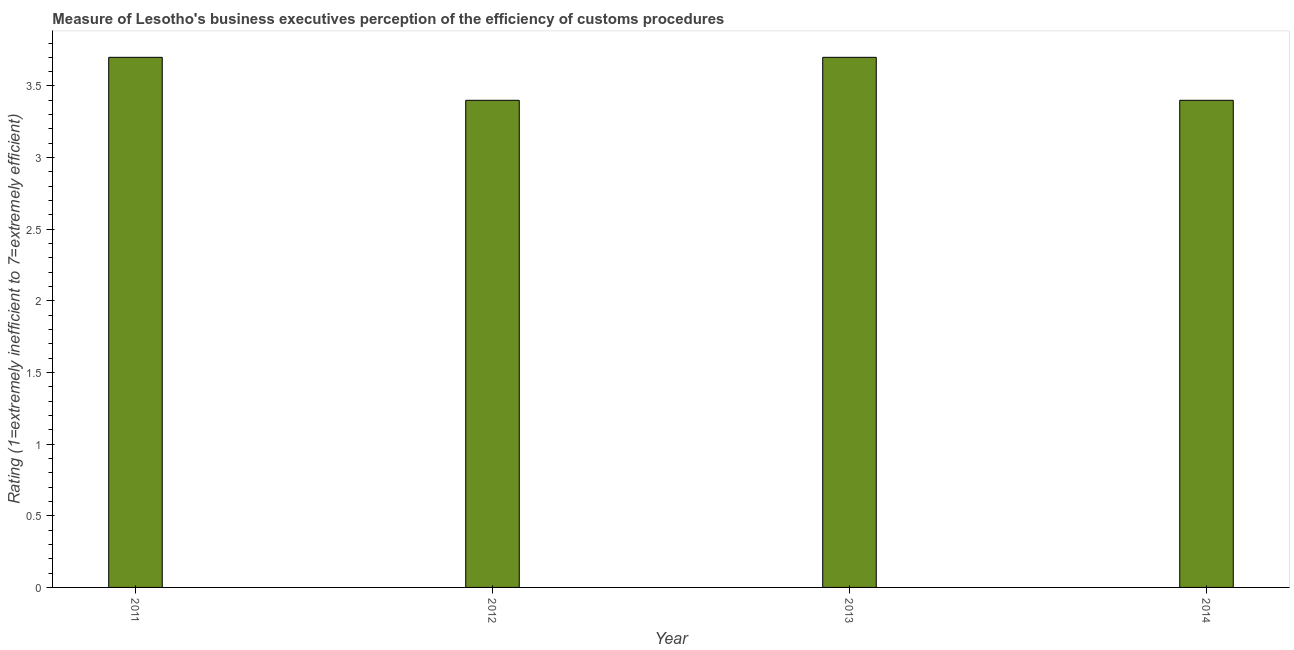Does the graph contain any zero values?
Make the answer very short. No. Does the graph contain grids?
Your answer should be very brief. No. What is the title of the graph?
Your answer should be very brief. Measure of Lesotho's business executives perception of the efficiency of customs procedures. What is the label or title of the X-axis?
Provide a short and direct response. Year. What is the label or title of the Y-axis?
Provide a succinct answer. Rating (1=extremely inefficient to 7=extremely efficient). What is the rating measuring burden of customs procedure in 2011?
Provide a short and direct response. 3.7. Across all years, what is the minimum rating measuring burden of customs procedure?
Your answer should be compact. 3.4. In which year was the rating measuring burden of customs procedure maximum?
Offer a very short reply. 2011. In which year was the rating measuring burden of customs procedure minimum?
Give a very brief answer. 2012. What is the sum of the rating measuring burden of customs procedure?
Your answer should be compact. 14.2. What is the average rating measuring burden of customs procedure per year?
Your answer should be very brief. 3.55. What is the median rating measuring burden of customs procedure?
Provide a short and direct response. 3.55. In how many years, is the rating measuring burden of customs procedure greater than 3.4 ?
Your response must be concise. 2. Do a majority of the years between 2011 and 2013 (inclusive) have rating measuring burden of customs procedure greater than 3.2 ?
Keep it short and to the point. Yes. What is the ratio of the rating measuring burden of customs procedure in 2013 to that in 2014?
Make the answer very short. 1.09. Is the rating measuring burden of customs procedure in 2012 less than that in 2014?
Offer a very short reply. No. Is the sum of the rating measuring burden of customs procedure in 2011 and 2013 greater than the maximum rating measuring burden of customs procedure across all years?
Provide a succinct answer. Yes. In how many years, is the rating measuring burden of customs procedure greater than the average rating measuring burden of customs procedure taken over all years?
Ensure brevity in your answer.  2. How many bars are there?
Ensure brevity in your answer.  4. Are all the bars in the graph horizontal?
Provide a short and direct response. No. What is the difference between two consecutive major ticks on the Y-axis?
Keep it short and to the point. 0.5. Are the values on the major ticks of Y-axis written in scientific E-notation?
Keep it short and to the point. No. What is the Rating (1=extremely inefficient to 7=extremely efficient) in 2013?
Offer a very short reply. 3.7. What is the difference between the Rating (1=extremely inefficient to 7=extremely efficient) in 2011 and 2014?
Offer a terse response. 0.3. What is the difference between the Rating (1=extremely inefficient to 7=extremely efficient) in 2012 and 2014?
Offer a very short reply. 0. What is the difference between the Rating (1=extremely inefficient to 7=extremely efficient) in 2013 and 2014?
Provide a short and direct response. 0.3. What is the ratio of the Rating (1=extremely inefficient to 7=extremely efficient) in 2011 to that in 2012?
Make the answer very short. 1.09. What is the ratio of the Rating (1=extremely inefficient to 7=extremely efficient) in 2011 to that in 2014?
Ensure brevity in your answer.  1.09. What is the ratio of the Rating (1=extremely inefficient to 7=extremely efficient) in 2012 to that in 2013?
Provide a short and direct response. 0.92. What is the ratio of the Rating (1=extremely inefficient to 7=extremely efficient) in 2013 to that in 2014?
Offer a very short reply. 1.09. 